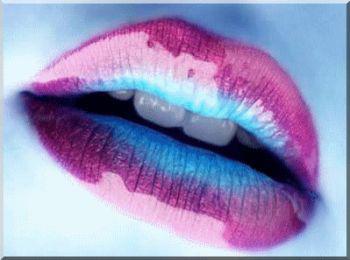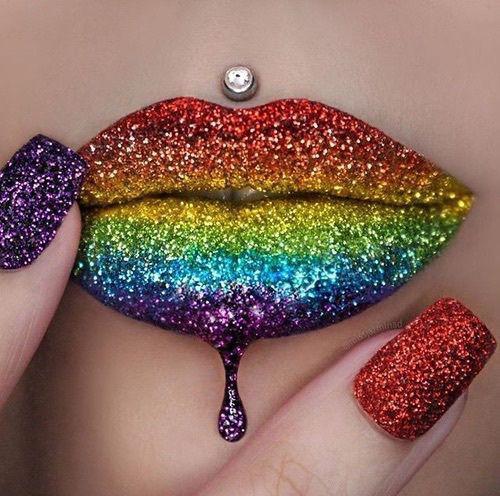The first image is the image on the left, the second image is the image on the right. Assess this claim about the two images: "One of the lips has a piercing directly above the upper lip that is not attached to the nose.". Correct or not? Answer yes or no. Yes. The first image is the image on the left, the second image is the image on the right. Analyze the images presented: Is the assertion "A single rhinestone stud is directly above a pair of glittery lips in one image." valid? Answer yes or no. Yes. 